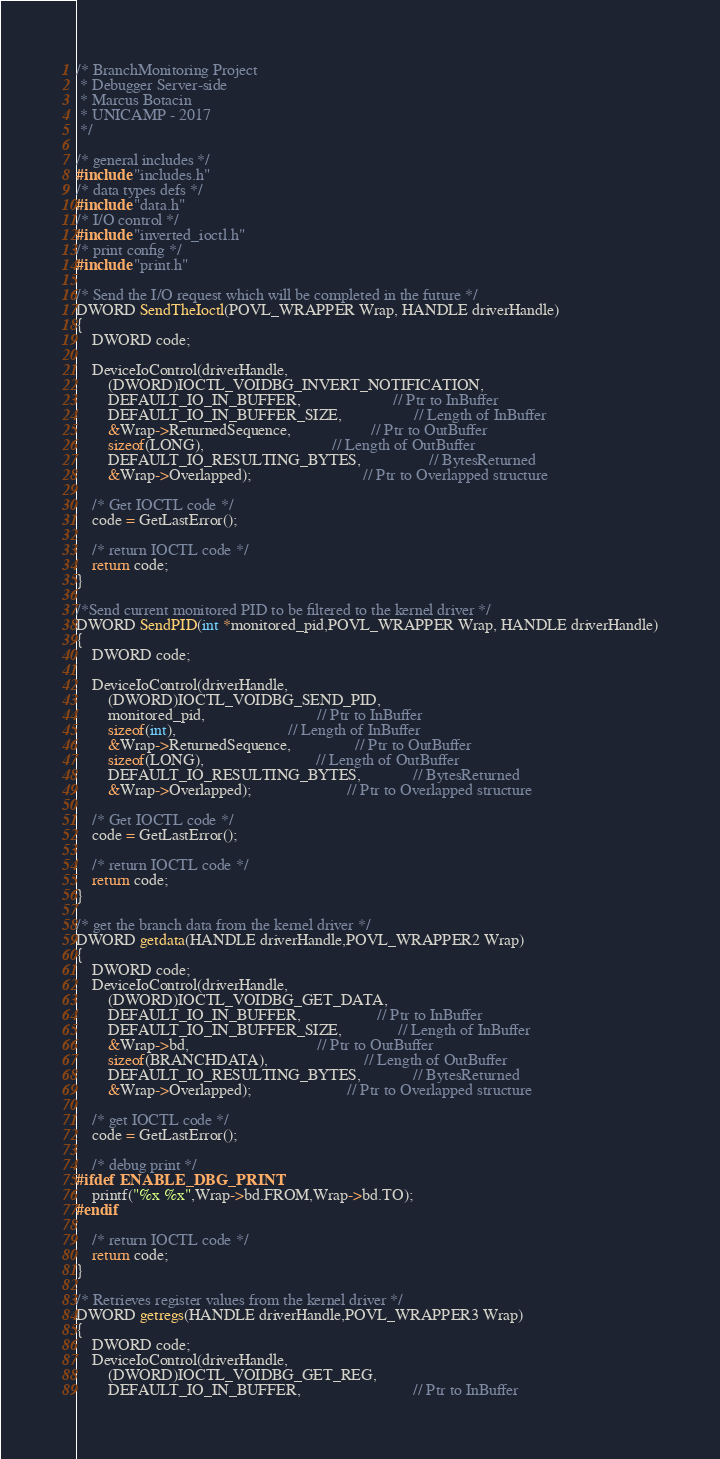Convert code to text. <code><loc_0><loc_0><loc_500><loc_500><_C++_>/* BranchMonitoring Project 
 * Debugger Server-side
 * Marcus Botacin
 * UNICAMP - 2017
 */

/* general includes */
#include "includes.h"
/* data types defs */
#include "data.h"
/* I/O control */
#include "inverted_ioctl.h"
/* print config */
#include "print.h"

/* Send the I/O request which will be completed in the future */
DWORD SendTheIoctl(POVL_WRAPPER Wrap, HANDLE driverHandle)
{
	DWORD code;

	DeviceIoControl(driverHandle,
		(DWORD)IOCTL_VOIDBG_INVERT_NOTIFICATION,
		DEFAULT_IO_IN_BUFFER,                       // Ptr to InBuffer
		DEFAULT_IO_IN_BUFFER_SIZE,                  // Length of InBuffer
		&Wrap->ReturnedSequence,					// Ptr to OutBuffer
		sizeof(LONG),								// Length of OutBuffer
		DEFAULT_IO_RESULTING_BYTES,                 // BytesReturned
		&Wrap->Overlapped);							// Ptr to Overlapped structure

	/* Get IOCTL code */
	code = GetLastError();

	/* return IOCTL code */
	return code;
}

/*Send current monitored PID to be filtered to the kernel driver */
DWORD SendPID(int *monitored_pid,POVL_WRAPPER Wrap, HANDLE driverHandle)
{
	DWORD code;

	DeviceIoControl(driverHandle,
		(DWORD)IOCTL_VOIDBG_SEND_PID,
		monitored_pid,							// Ptr to InBuffer
		sizeof(int),							// Length of InBuffer
		&Wrap->ReturnedSequence,				// Ptr to OutBuffer
		sizeof(LONG),							// Length of OutBuffer
		DEFAULT_IO_RESULTING_BYTES,             // BytesReturned
		&Wrap->Overlapped);						// Ptr to Overlapped structure

	/* Get IOCTL code */
	code = GetLastError();

	/* return IOCTL code */
	return code;
}

/* get the branch data from the kernel driver */
DWORD getdata(HANDLE driverHandle,POVL_WRAPPER2 Wrap)
{
	DWORD code;
	DeviceIoControl(driverHandle,
		(DWORD)IOCTL_VOIDBG_GET_DATA,
		DEFAULT_IO_IN_BUFFER,                   // Ptr to InBuffer
		DEFAULT_IO_IN_BUFFER_SIZE,              // Length of InBuffer
		&Wrap->bd,								// Ptr to OutBuffer
		sizeof(BRANCHDATA),						// Length of OutBuffer
		DEFAULT_IO_RESULTING_BYTES,             // BytesReturned
		&Wrap->Overlapped);						// Ptr to Overlapped structure

	/* get IOCTL code */
	code = GetLastError();

	/* debug print */
#ifdef ENABLE_DBG_PRINT
	printf("%x %x",Wrap->bd.FROM,Wrap->bd.TO);
#endif

	/* return IOCTL code */
	return code;
}

/* Retrieves register values from the kernel driver */
DWORD getregs(HANDLE driverHandle,POVL_WRAPPER3 Wrap)
{
	DWORD code;
	DeviceIoControl(driverHandle,
		(DWORD)IOCTL_VOIDBG_GET_REG,
		DEFAULT_IO_IN_BUFFER,							// Ptr to InBuffer</code> 